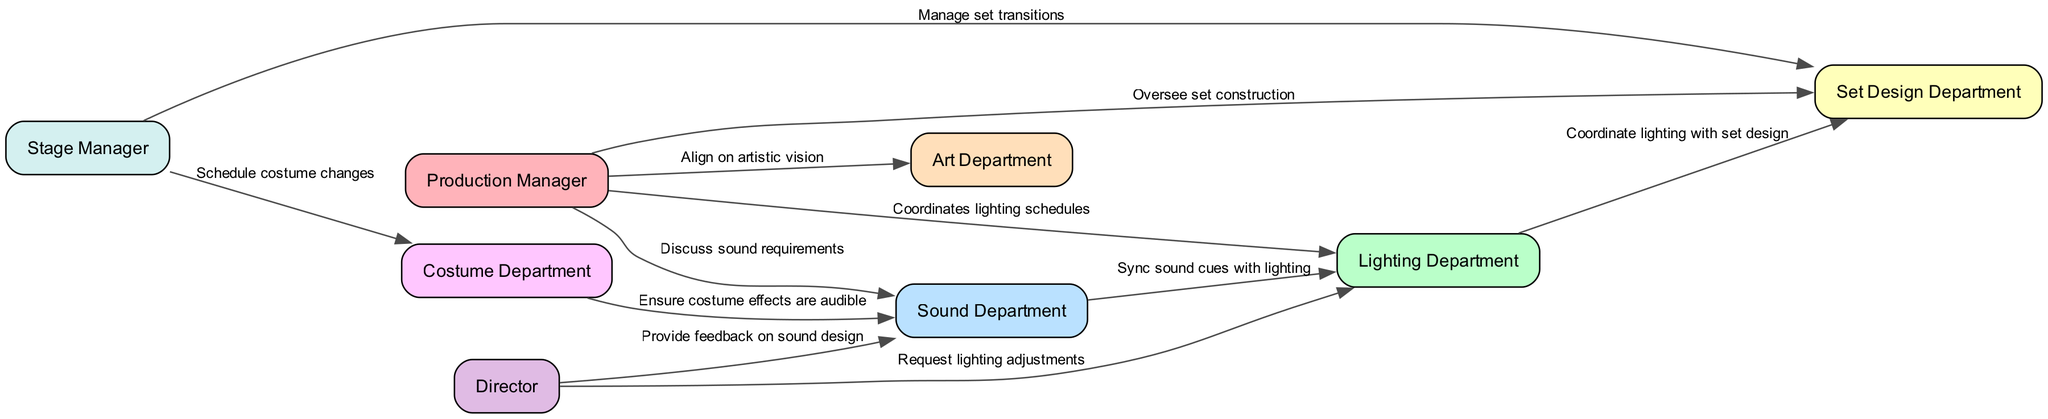What is the total number of nodes in the diagram? The diagram contains a total of 8 nodes representing different departments and individuals involved in the production. Each node is listed in the provided data under "nodes".
Answer: 8 Which department does the Production Manager coordinate with primarily on lighting? The edge labeled "Coordinates lighting schedules" connects the Production Manager to the Lighting Department, indicating this coordination.
Answer: Lighting Department How many edges connect the Sound Department to other departments? There are three edges connecting the Sound Department: one to the Production Manager, one to the Lighting Department, and one to the Costume Department. This information can be counted directly from the "edges" data.
Answer: 3 What role provides feedback on sound design to the Sound Department? The Director is indicated to provide feedback via the edge labeled "Provide feedback on sound design" that connects to the Sound Department.
Answer: Director Which two departments coordinate for lighting adjustments and ensure costume effects are audible? The Lighting Department and the Costume Department are involved with lighting adjustments and audible costume effects, respectively. The Lighting Department coordinates with the Sound Department, while the Costume Department ensures that effects are audible via its edge connection with the Sound Department.
Answer: Lighting and Costume Departments Which department does the Stage Manager manage transitions for? The edge labeled "Manage set transitions" indicates that the Stage Manager manages transitions for the Set Design Department. This is directly stated in the edges provided.
Answer: Set Design Department Is there a direct line of communication between the Lighting Department and the Set Design Department? Yes, the edge labeled "Coordinate lighting with set design" indicates a direct line of communication between these two departments.
Answer: Yes Which department aligns on the artistic vision with the Production Manager? The Production Manager aligns on artistic vision with the Art Department as indicated by the edge labeled "Align on artistic vision."
Answer: Art Department How many departments does the Stage Manager coordinate with? The Stage Manager coordinates with two departments: the Set Design Department and the Costume Department, as shown in the edges that connect to those departments.
Answer: 2 